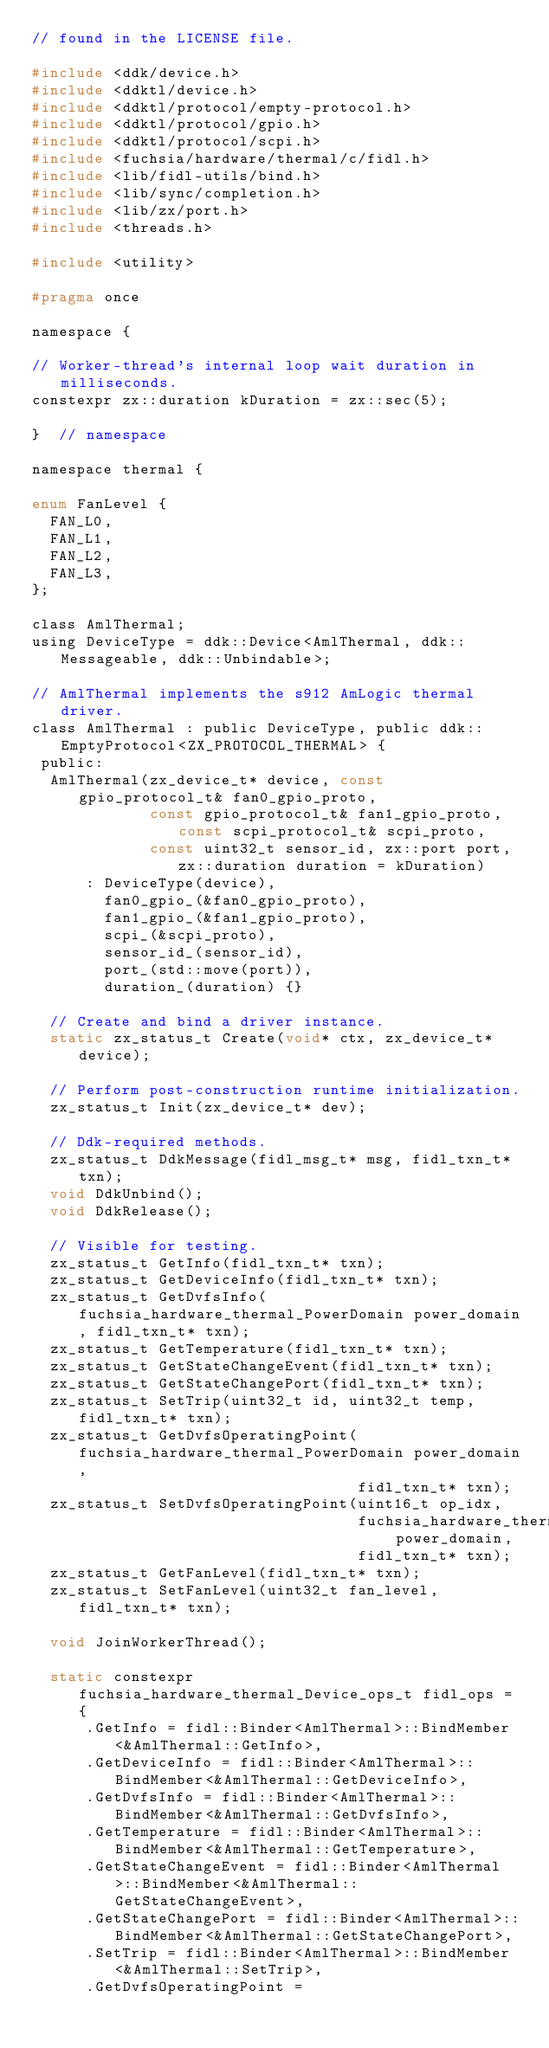<code> <loc_0><loc_0><loc_500><loc_500><_C_>// found in the LICENSE file.

#include <ddk/device.h>
#include <ddktl/device.h>
#include <ddktl/protocol/empty-protocol.h>
#include <ddktl/protocol/gpio.h>
#include <ddktl/protocol/scpi.h>
#include <fuchsia/hardware/thermal/c/fidl.h>
#include <lib/fidl-utils/bind.h>
#include <lib/sync/completion.h>
#include <lib/zx/port.h>
#include <threads.h>

#include <utility>

#pragma once

namespace {

// Worker-thread's internal loop wait duration in milliseconds.
constexpr zx::duration kDuration = zx::sec(5);

}  // namespace

namespace thermal {

enum FanLevel {
  FAN_L0,
  FAN_L1,
  FAN_L2,
  FAN_L3,
};

class AmlThermal;
using DeviceType = ddk::Device<AmlThermal, ddk::Messageable, ddk::Unbindable>;

// AmlThermal implements the s912 AmLogic thermal driver.
class AmlThermal : public DeviceType, public ddk::EmptyProtocol<ZX_PROTOCOL_THERMAL> {
 public:
  AmlThermal(zx_device_t* device, const gpio_protocol_t& fan0_gpio_proto,
             const gpio_protocol_t& fan1_gpio_proto, const scpi_protocol_t& scpi_proto,
             const uint32_t sensor_id, zx::port port, zx::duration duration = kDuration)
      : DeviceType(device),
        fan0_gpio_(&fan0_gpio_proto),
        fan1_gpio_(&fan1_gpio_proto),
        scpi_(&scpi_proto),
        sensor_id_(sensor_id),
        port_(std::move(port)),
        duration_(duration) {}

  // Create and bind a driver instance.
  static zx_status_t Create(void* ctx, zx_device_t* device);

  // Perform post-construction runtime initialization.
  zx_status_t Init(zx_device_t* dev);

  // Ddk-required methods.
  zx_status_t DdkMessage(fidl_msg_t* msg, fidl_txn_t* txn);
  void DdkUnbind();
  void DdkRelease();

  // Visible for testing.
  zx_status_t GetInfo(fidl_txn_t* txn);
  zx_status_t GetDeviceInfo(fidl_txn_t* txn);
  zx_status_t GetDvfsInfo(fuchsia_hardware_thermal_PowerDomain power_domain, fidl_txn_t* txn);
  zx_status_t GetTemperature(fidl_txn_t* txn);
  zx_status_t GetStateChangeEvent(fidl_txn_t* txn);
  zx_status_t GetStateChangePort(fidl_txn_t* txn);
  zx_status_t SetTrip(uint32_t id, uint32_t temp, fidl_txn_t* txn);
  zx_status_t GetDvfsOperatingPoint(fuchsia_hardware_thermal_PowerDomain power_domain,
                                    fidl_txn_t* txn);
  zx_status_t SetDvfsOperatingPoint(uint16_t op_idx,
                                    fuchsia_hardware_thermal_PowerDomain power_domain,
                                    fidl_txn_t* txn);
  zx_status_t GetFanLevel(fidl_txn_t* txn);
  zx_status_t SetFanLevel(uint32_t fan_level, fidl_txn_t* txn);

  void JoinWorkerThread();

  static constexpr fuchsia_hardware_thermal_Device_ops_t fidl_ops = {
      .GetInfo = fidl::Binder<AmlThermal>::BindMember<&AmlThermal::GetInfo>,
      .GetDeviceInfo = fidl::Binder<AmlThermal>::BindMember<&AmlThermal::GetDeviceInfo>,
      .GetDvfsInfo = fidl::Binder<AmlThermal>::BindMember<&AmlThermal::GetDvfsInfo>,
      .GetTemperature = fidl::Binder<AmlThermal>::BindMember<&AmlThermal::GetTemperature>,
      .GetStateChangeEvent = fidl::Binder<AmlThermal>::BindMember<&AmlThermal::GetStateChangeEvent>,
      .GetStateChangePort = fidl::Binder<AmlThermal>::BindMember<&AmlThermal::GetStateChangePort>,
      .SetTrip = fidl::Binder<AmlThermal>::BindMember<&AmlThermal::SetTrip>,
      .GetDvfsOperatingPoint =</code> 